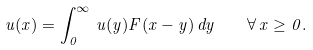Convert formula to latex. <formula><loc_0><loc_0><loc_500><loc_500>u ( x ) = \int _ { 0 } ^ { \infty } \, u ( y ) F ( x - y ) \, d y \quad \forall \, x \geq 0 .</formula> 